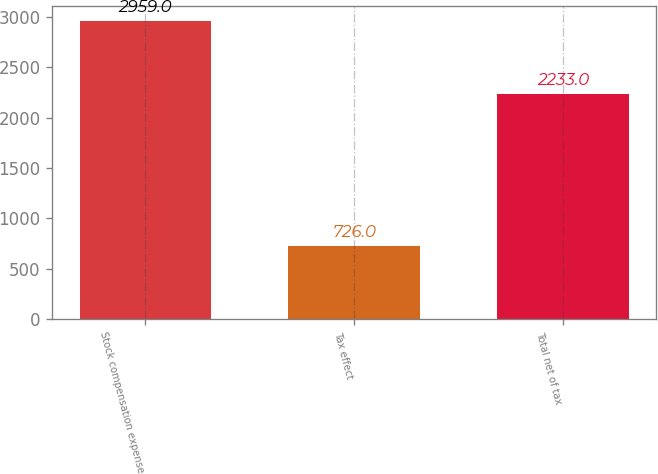<chart> <loc_0><loc_0><loc_500><loc_500><bar_chart><fcel>Stock compensation expense<fcel>Tax effect<fcel>Total net of tax<nl><fcel>2959<fcel>726<fcel>2233<nl></chart> 